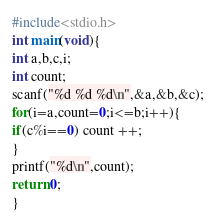<code> <loc_0><loc_0><loc_500><loc_500><_C_>#include<stdio.h>
int main(void){
int a,b,c,i;
int count;
scanf("%d %d %d\n",&a,&b,&c);
for(i=a,count=0;i<=b;i++){
if(c%i==0) count ++;
}
printf("%d\n",count);
return 0;
}</code> 